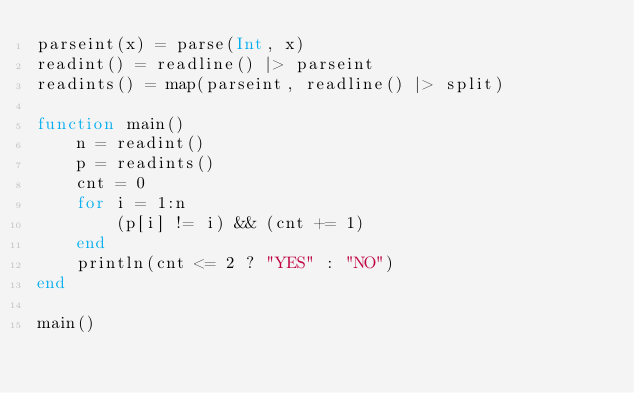<code> <loc_0><loc_0><loc_500><loc_500><_Julia_>parseint(x) = parse(Int, x)
readint() = readline() |> parseint
readints() = map(parseint, readline() |> split)

function main()
    n = readint()
    p = readints()
    cnt = 0
    for i = 1:n
        (p[i] != i) && (cnt += 1)
    end
    println(cnt <= 2 ? "YES" : "NO")
end

main()</code> 